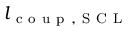Convert formula to latex. <formula><loc_0><loc_0><loc_500><loc_500>l _ { c o u p , S C L }</formula> 